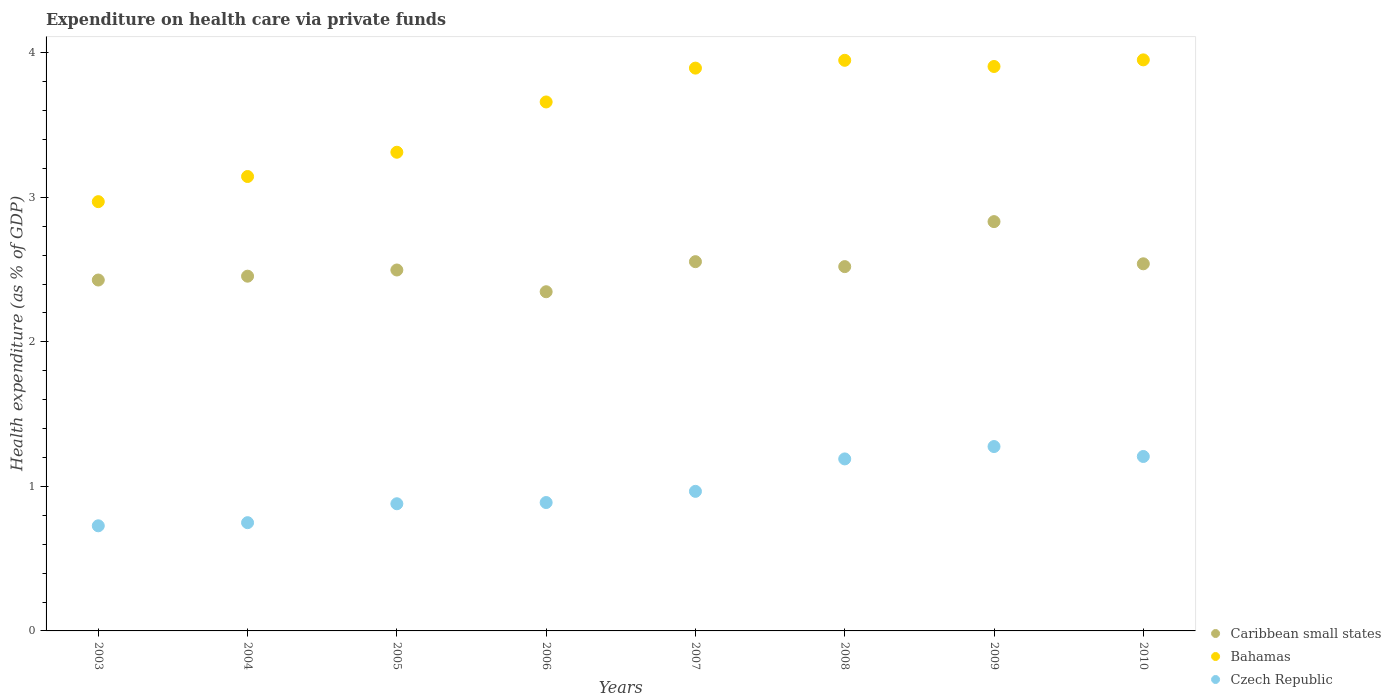Is the number of dotlines equal to the number of legend labels?
Your answer should be compact. Yes. What is the expenditure made on health care in Czech Republic in 2004?
Give a very brief answer. 0.75. Across all years, what is the maximum expenditure made on health care in Caribbean small states?
Your response must be concise. 2.83. Across all years, what is the minimum expenditure made on health care in Bahamas?
Offer a terse response. 2.97. In which year was the expenditure made on health care in Caribbean small states maximum?
Your response must be concise. 2009. In which year was the expenditure made on health care in Czech Republic minimum?
Offer a terse response. 2003. What is the total expenditure made on health care in Caribbean small states in the graph?
Your answer should be very brief. 20.17. What is the difference between the expenditure made on health care in Bahamas in 2006 and that in 2007?
Offer a very short reply. -0.23. What is the difference between the expenditure made on health care in Czech Republic in 2004 and the expenditure made on health care in Bahamas in 2003?
Your answer should be very brief. -2.22. What is the average expenditure made on health care in Czech Republic per year?
Make the answer very short. 0.99. In the year 2003, what is the difference between the expenditure made on health care in Bahamas and expenditure made on health care in Czech Republic?
Ensure brevity in your answer.  2.24. What is the ratio of the expenditure made on health care in Caribbean small states in 2004 to that in 2007?
Make the answer very short. 0.96. Is the expenditure made on health care in Czech Republic in 2005 less than that in 2006?
Your answer should be compact. Yes. Is the difference between the expenditure made on health care in Bahamas in 2006 and 2007 greater than the difference between the expenditure made on health care in Czech Republic in 2006 and 2007?
Keep it short and to the point. No. What is the difference between the highest and the second highest expenditure made on health care in Czech Republic?
Give a very brief answer. 0.07. What is the difference between the highest and the lowest expenditure made on health care in Caribbean small states?
Your answer should be compact. 0.49. In how many years, is the expenditure made on health care in Bahamas greater than the average expenditure made on health care in Bahamas taken over all years?
Your answer should be compact. 5. Is the sum of the expenditure made on health care in Bahamas in 2007 and 2009 greater than the maximum expenditure made on health care in Caribbean small states across all years?
Ensure brevity in your answer.  Yes. Is the expenditure made on health care in Bahamas strictly greater than the expenditure made on health care in Czech Republic over the years?
Offer a terse response. Yes. Is the expenditure made on health care in Czech Republic strictly less than the expenditure made on health care in Caribbean small states over the years?
Ensure brevity in your answer.  Yes. What is the title of the graph?
Provide a succinct answer. Expenditure on health care via private funds. Does "Channel Islands" appear as one of the legend labels in the graph?
Offer a terse response. No. What is the label or title of the Y-axis?
Your response must be concise. Health expenditure (as % of GDP). What is the Health expenditure (as % of GDP) of Caribbean small states in 2003?
Your answer should be very brief. 2.43. What is the Health expenditure (as % of GDP) in Bahamas in 2003?
Provide a succinct answer. 2.97. What is the Health expenditure (as % of GDP) of Czech Republic in 2003?
Your answer should be very brief. 0.73. What is the Health expenditure (as % of GDP) in Caribbean small states in 2004?
Your answer should be very brief. 2.45. What is the Health expenditure (as % of GDP) in Bahamas in 2004?
Offer a terse response. 3.14. What is the Health expenditure (as % of GDP) of Czech Republic in 2004?
Give a very brief answer. 0.75. What is the Health expenditure (as % of GDP) in Caribbean small states in 2005?
Your answer should be compact. 2.5. What is the Health expenditure (as % of GDP) of Bahamas in 2005?
Offer a very short reply. 3.31. What is the Health expenditure (as % of GDP) of Czech Republic in 2005?
Offer a very short reply. 0.88. What is the Health expenditure (as % of GDP) of Caribbean small states in 2006?
Your response must be concise. 2.35. What is the Health expenditure (as % of GDP) in Bahamas in 2006?
Your answer should be very brief. 3.66. What is the Health expenditure (as % of GDP) of Czech Republic in 2006?
Ensure brevity in your answer.  0.89. What is the Health expenditure (as % of GDP) of Caribbean small states in 2007?
Your response must be concise. 2.55. What is the Health expenditure (as % of GDP) of Bahamas in 2007?
Your answer should be very brief. 3.89. What is the Health expenditure (as % of GDP) in Czech Republic in 2007?
Keep it short and to the point. 0.97. What is the Health expenditure (as % of GDP) in Caribbean small states in 2008?
Give a very brief answer. 2.52. What is the Health expenditure (as % of GDP) of Bahamas in 2008?
Offer a terse response. 3.95. What is the Health expenditure (as % of GDP) in Czech Republic in 2008?
Offer a very short reply. 1.19. What is the Health expenditure (as % of GDP) in Caribbean small states in 2009?
Ensure brevity in your answer.  2.83. What is the Health expenditure (as % of GDP) in Bahamas in 2009?
Keep it short and to the point. 3.91. What is the Health expenditure (as % of GDP) in Czech Republic in 2009?
Provide a short and direct response. 1.28. What is the Health expenditure (as % of GDP) of Caribbean small states in 2010?
Your answer should be compact. 2.54. What is the Health expenditure (as % of GDP) in Bahamas in 2010?
Ensure brevity in your answer.  3.95. What is the Health expenditure (as % of GDP) of Czech Republic in 2010?
Give a very brief answer. 1.21. Across all years, what is the maximum Health expenditure (as % of GDP) in Caribbean small states?
Offer a terse response. 2.83. Across all years, what is the maximum Health expenditure (as % of GDP) of Bahamas?
Give a very brief answer. 3.95. Across all years, what is the maximum Health expenditure (as % of GDP) of Czech Republic?
Keep it short and to the point. 1.28. Across all years, what is the minimum Health expenditure (as % of GDP) in Caribbean small states?
Offer a terse response. 2.35. Across all years, what is the minimum Health expenditure (as % of GDP) in Bahamas?
Offer a very short reply. 2.97. Across all years, what is the minimum Health expenditure (as % of GDP) of Czech Republic?
Offer a terse response. 0.73. What is the total Health expenditure (as % of GDP) in Caribbean small states in the graph?
Ensure brevity in your answer.  20.17. What is the total Health expenditure (as % of GDP) in Bahamas in the graph?
Offer a very short reply. 28.78. What is the total Health expenditure (as % of GDP) of Czech Republic in the graph?
Provide a succinct answer. 7.88. What is the difference between the Health expenditure (as % of GDP) in Caribbean small states in 2003 and that in 2004?
Ensure brevity in your answer.  -0.03. What is the difference between the Health expenditure (as % of GDP) of Bahamas in 2003 and that in 2004?
Your answer should be compact. -0.17. What is the difference between the Health expenditure (as % of GDP) in Czech Republic in 2003 and that in 2004?
Give a very brief answer. -0.02. What is the difference between the Health expenditure (as % of GDP) of Caribbean small states in 2003 and that in 2005?
Your answer should be very brief. -0.07. What is the difference between the Health expenditure (as % of GDP) in Bahamas in 2003 and that in 2005?
Ensure brevity in your answer.  -0.34. What is the difference between the Health expenditure (as % of GDP) of Czech Republic in 2003 and that in 2005?
Ensure brevity in your answer.  -0.15. What is the difference between the Health expenditure (as % of GDP) of Caribbean small states in 2003 and that in 2006?
Give a very brief answer. 0.08. What is the difference between the Health expenditure (as % of GDP) of Bahamas in 2003 and that in 2006?
Offer a very short reply. -0.69. What is the difference between the Health expenditure (as % of GDP) in Czech Republic in 2003 and that in 2006?
Offer a terse response. -0.16. What is the difference between the Health expenditure (as % of GDP) in Caribbean small states in 2003 and that in 2007?
Your answer should be very brief. -0.13. What is the difference between the Health expenditure (as % of GDP) of Bahamas in 2003 and that in 2007?
Give a very brief answer. -0.92. What is the difference between the Health expenditure (as % of GDP) in Czech Republic in 2003 and that in 2007?
Your response must be concise. -0.24. What is the difference between the Health expenditure (as % of GDP) of Caribbean small states in 2003 and that in 2008?
Provide a succinct answer. -0.09. What is the difference between the Health expenditure (as % of GDP) in Bahamas in 2003 and that in 2008?
Your answer should be very brief. -0.98. What is the difference between the Health expenditure (as % of GDP) in Czech Republic in 2003 and that in 2008?
Your answer should be very brief. -0.46. What is the difference between the Health expenditure (as % of GDP) of Caribbean small states in 2003 and that in 2009?
Offer a terse response. -0.4. What is the difference between the Health expenditure (as % of GDP) in Bahamas in 2003 and that in 2009?
Your response must be concise. -0.94. What is the difference between the Health expenditure (as % of GDP) of Czech Republic in 2003 and that in 2009?
Offer a terse response. -0.55. What is the difference between the Health expenditure (as % of GDP) of Caribbean small states in 2003 and that in 2010?
Offer a terse response. -0.11. What is the difference between the Health expenditure (as % of GDP) of Bahamas in 2003 and that in 2010?
Keep it short and to the point. -0.98. What is the difference between the Health expenditure (as % of GDP) of Czech Republic in 2003 and that in 2010?
Your response must be concise. -0.48. What is the difference between the Health expenditure (as % of GDP) of Caribbean small states in 2004 and that in 2005?
Provide a succinct answer. -0.04. What is the difference between the Health expenditure (as % of GDP) in Bahamas in 2004 and that in 2005?
Keep it short and to the point. -0.17. What is the difference between the Health expenditure (as % of GDP) in Czech Republic in 2004 and that in 2005?
Ensure brevity in your answer.  -0.13. What is the difference between the Health expenditure (as % of GDP) of Caribbean small states in 2004 and that in 2006?
Provide a succinct answer. 0.11. What is the difference between the Health expenditure (as % of GDP) in Bahamas in 2004 and that in 2006?
Your response must be concise. -0.52. What is the difference between the Health expenditure (as % of GDP) of Czech Republic in 2004 and that in 2006?
Provide a short and direct response. -0.14. What is the difference between the Health expenditure (as % of GDP) in Caribbean small states in 2004 and that in 2007?
Your response must be concise. -0.1. What is the difference between the Health expenditure (as % of GDP) in Bahamas in 2004 and that in 2007?
Offer a very short reply. -0.75. What is the difference between the Health expenditure (as % of GDP) in Czech Republic in 2004 and that in 2007?
Give a very brief answer. -0.22. What is the difference between the Health expenditure (as % of GDP) of Caribbean small states in 2004 and that in 2008?
Keep it short and to the point. -0.07. What is the difference between the Health expenditure (as % of GDP) of Bahamas in 2004 and that in 2008?
Give a very brief answer. -0.8. What is the difference between the Health expenditure (as % of GDP) in Czech Republic in 2004 and that in 2008?
Make the answer very short. -0.44. What is the difference between the Health expenditure (as % of GDP) of Caribbean small states in 2004 and that in 2009?
Provide a succinct answer. -0.38. What is the difference between the Health expenditure (as % of GDP) of Bahamas in 2004 and that in 2009?
Your answer should be compact. -0.76. What is the difference between the Health expenditure (as % of GDP) in Czech Republic in 2004 and that in 2009?
Give a very brief answer. -0.53. What is the difference between the Health expenditure (as % of GDP) of Caribbean small states in 2004 and that in 2010?
Provide a short and direct response. -0.09. What is the difference between the Health expenditure (as % of GDP) in Bahamas in 2004 and that in 2010?
Offer a very short reply. -0.81. What is the difference between the Health expenditure (as % of GDP) in Czech Republic in 2004 and that in 2010?
Keep it short and to the point. -0.46. What is the difference between the Health expenditure (as % of GDP) of Caribbean small states in 2005 and that in 2006?
Give a very brief answer. 0.15. What is the difference between the Health expenditure (as % of GDP) of Bahamas in 2005 and that in 2006?
Offer a terse response. -0.35. What is the difference between the Health expenditure (as % of GDP) of Czech Republic in 2005 and that in 2006?
Give a very brief answer. -0.01. What is the difference between the Health expenditure (as % of GDP) of Caribbean small states in 2005 and that in 2007?
Offer a very short reply. -0.06. What is the difference between the Health expenditure (as % of GDP) in Bahamas in 2005 and that in 2007?
Offer a very short reply. -0.58. What is the difference between the Health expenditure (as % of GDP) of Czech Republic in 2005 and that in 2007?
Your answer should be very brief. -0.09. What is the difference between the Health expenditure (as % of GDP) in Caribbean small states in 2005 and that in 2008?
Provide a short and direct response. -0.02. What is the difference between the Health expenditure (as % of GDP) of Bahamas in 2005 and that in 2008?
Make the answer very short. -0.64. What is the difference between the Health expenditure (as % of GDP) of Czech Republic in 2005 and that in 2008?
Your answer should be compact. -0.31. What is the difference between the Health expenditure (as % of GDP) in Caribbean small states in 2005 and that in 2009?
Your response must be concise. -0.33. What is the difference between the Health expenditure (as % of GDP) in Bahamas in 2005 and that in 2009?
Offer a terse response. -0.59. What is the difference between the Health expenditure (as % of GDP) in Czech Republic in 2005 and that in 2009?
Offer a terse response. -0.4. What is the difference between the Health expenditure (as % of GDP) in Caribbean small states in 2005 and that in 2010?
Provide a succinct answer. -0.04. What is the difference between the Health expenditure (as % of GDP) in Bahamas in 2005 and that in 2010?
Your response must be concise. -0.64. What is the difference between the Health expenditure (as % of GDP) in Czech Republic in 2005 and that in 2010?
Your answer should be very brief. -0.33. What is the difference between the Health expenditure (as % of GDP) in Caribbean small states in 2006 and that in 2007?
Provide a short and direct response. -0.21. What is the difference between the Health expenditure (as % of GDP) in Bahamas in 2006 and that in 2007?
Your answer should be very brief. -0.23. What is the difference between the Health expenditure (as % of GDP) of Czech Republic in 2006 and that in 2007?
Provide a short and direct response. -0.08. What is the difference between the Health expenditure (as % of GDP) of Caribbean small states in 2006 and that in 2008?
Keep it short and to the point. -0.17. What is the difference between the Health expenditure (as % of GDP) in Bahamas in 2006 and that in 2008?
Your answer should be compact. -0.29. What is the difference between the Health expenditure (as % of GDP) of Czech Republic in 2006 and that in 2008?
Keep it short and to the point. -0.3. What is the difference between the Health expenditure (as % of GDP) of Caribbean small states in 2006 and that in 2009?
Provide a succinct answer. -0.49. What is the difference between the Health expenditure (as % of GDP) in Bahamas in 2006 and that in 2009?
Ensure brevity in your answer.  -0.25. What is the difference between the Health expenditure (as % of GDP) in Czech Republic in 2006 and that in 2009?
Offer a very short reply. -0.39. What is the difference between the Health expenditure (as % of GDP) in Caribbean small states in 2006 and that in 2010?
Provide a short and direct response. -0.19. What is the difference between the Health expenditure (as % of GDP) in Bahamas in 2006 and that in 2010?
Your answer should be very brief. -0.29. What is the difference between the Health expenditure (as % of GDP) of Czech Republic in 2006 and that in 2010?
Ensure brevity in your answer.  -0.32. What is the difference between the Health expenditure (as % of GDP) in Caribbean small states in 2007 and that in 2008?
Your response must be concise. 0.03. What is the difference between the Health expenditure (as % of GDP) in Bahamas in 2007 and that in 2008?
Offer a terse response. -0.05. What is the difference between the Health expenditure (as % of GDP) in Czech Republic in 2007 and that in 2008?
Your response must be concise. -0.22. What is the difference between the Health expenditure (as % of GDP) in Caribbean small states in 2007 and that in 2009?
Your response must be concise. -0.28. What is the difference between the Health expenditure (as % of GDP) of Bahamas in 2007 and that in 2009?
Make the answer very short. -0.01. What is the difference between the Health expenditure (as % of GDP) in Czech Republic in 2007 and that in 2009?
Ensure brevity in your answer.  -0.31. What is the difference between the Health expenditure (as % of GDP) in Caribbean small states in 2007 and that in 2010?
Ensure brevity in your answer.  0.01. What is the difference between the Health expenditure (as % of GDP) in Bahamas in 2007 and that in 2010?
Provide a succinct answer. -0.06. What is the difference between the Health expenditure (as % of GDP) in Czech Republic in 2007 and that in 2010?
Provide a succinct answer. -0.24. What is the difference between the Health expenditure (as % of GDP) of Caribbean small states in 2008 and that in 2009?
Ensure brevity in your answer.  -0.31. What is the difference between the Health expenditure (as % of GDP) in Bahamas in 2008 and that in 2009?
Provide a succinct answer. 0.04. What is the difference between the Health expenditure (as % of GDP) of Czech Republic in 2008 and that in 2009?
Provide a succinct answer. -0.09. What is the difference between the Health expenditure (as % of GDP) of Caribbean small states in 2008 and that in 2010?
Provide a short and direct response. -0.02. What is the difference between the Health expenditure (as % of GDP) of Bahamas in 2008 and that in 2010?
Your answer should be compact. -0. What is the difference between the Health expenditure (as % of GDP) in Czech Republic in 2008 and that in 2010?
Give a very brief answer. -0.02. What is the difference between the Health expenditure (as % of GDP) in Caribbean small states in 2009 and that in 2010?
Provide a succinct answer. 0.29. What is the difference between the Health expenditure (as % of GDP) of Bahamas in 2009 and that in 2010?
Offer a terse response. -0.05. What is the difference between the Health expenditure (as % of GDP) of Czech Republic in 2009 and that in 2010?
Keep it short and to the point. 0.07. What is the difference between the Health expenditure (as % of GDP) of Caribbean small states in 2003 and the Health expenditure (as % of GDP) of Bahamas in 2004?
Offer a very short reply. -0.72. What is the difference between the Health expenditure (as % of GDP) of Caribbean small states in 2003 and the Health expenditure (as % of GDP) of Czech Republic in 2004?
Provide a succinct answer. 1.68. What is the difference between the Health expenditure (as % of GDP) in Bahamas in 2003 and the Health expenditure (as % of GDP) in Czech Republic in 2004?
Offer a terse response. 2.22. What is the difference between the Health expenditure (as % of GDP) in Caribbean small states in 2003 and the Health expenditure (as % of GDP) in Bahamas in 2005?
Provide a short and direct response. -0.88. What is the difference between the Health expenditure (as % of GDP) in Caribbean small states in 2003 and the Health expenditure (as % of GDP) in Czech Republic in 2005?
Your answer should be very brief. 1.55. What is the difference between the Health expenditure (as % of GDP) in Bahamas in 2003 and the Health expenditure (as % of GDP) in Czech Republic in 2005?
Keep it short and to the point. 2.09. What is the difference between the Health expenditure (as % of GDP) of Caribbean small states in 2003 and the Health expenditure (as % of GDP) of Bahamas in 2006?
Your answer should be compact. -1.23. What is the difference between the Health expenditure (as % of GDP) of Caribbean small states in 2003 and the Health expenditure (as % of GDP) of Czech Republic in 2006?
Provide a succinct answer. 1.54. What is the difference between the Health expenditure (as % of GDP) in Bahamas in 2003 and the Health expenditure (as % of GDP) in Czech Republic in 2006?
Offer a terse response. 2.08. What is the difference between the Health expenditure (as % of GDP) in Caribbean small states in 2003 and the Health expenditure (as % of GDP) in Bahamas in 2007?
Provide a succinct answer. -1.47. What is the difference between the Health expenditure (as % of GDP) of Caribbean small states in 2003 and the Health expenditure (as % of GDP) of Czech Republic in 2007?
Your response must be concise. 1.46. What is the difference between the Health expenditure (as % of GDP) in Bahamas in 2003 and the Health expenditure (as % of GDP) in Czech Republic in 2007?
Make the answer very short. 2. What is the difference between the Health expenditure (as % of GDP) of Caribbean small states in 2003 and the Health expenditure (as % of GDP) of Bahamas in 2008?
Your answer should be compact. -1.52. What is the difference between the Health expenditure (as % of GDP) in Caribbean small states in 2003 and the Health expenditure (as % of GDP) in Czech Republic in 2008?
Provide a succinct answer. 1.24. What is the difference between the Health expenditure (as % of GDP) in Bahamas in 2003 and the Health expenditure (as % of GDP) in Czech Republic in 2008?
Give a very brief answer. 1.78. What is the difference between the Health expenditure (as % of GDP) of Caribbean small states in 2003 and the Health expenditure (as % of GDP) of Bahamas in 2009?
Ensure brevity in your answer.  -1.48. What is the difference between the Health expenditure (as % of GDP) of Caribbean small states in 2003 and the Health expenditure (as % of GDP) of Czech Republic in 2009?
Your answer should be compact. 1.15. What is the difference between the Health expenditure (as % of GDP) in Bahamas in 2003 and the Health expenditure (as % of GDP) in Czech Republic in 2009?
Provide a succinct answer. 1.69. What is the difference between the Health expenditure (as % of GDP) in Caribbean small states in 2003 and the Health expenditure (as % of GDP) in Bahamas in 2010?
Provide a short and direct response. -1.52. What is the difference between the Health expenditure (as % of GDP) in Caribbean small states in 2003 and the Health expenditure (as % of GDP) in Czech Republic in 2010?
Provide a succinct answer. 1.22. What is the difference between the Health expenditure (as % of GDP) of Bahamas in 2003 and the Health expenditure (as % of GDP) of Czech Republic in 2010?
Provide a short and direct response. 1.76. What is the difference between the Health expenditure (as % of GDP) of Caribbean small states in 2004 and the Health expenditure (as % of GDP) of Bahamas in 2005?
Keep it short and to the point. -0.86. What is the difference between the Health expenditure (as % of GDP) in Caribbean small states in 2004 and the Health expenditure (as % of GDP) in Czech Republic in 2005?
Offer a very short reply. 1.57. What is the difference between the Health expenditure (as % of GDP) in Bahamas in 2004 and the Health expenditure (as % of GDP) in Czech Republic in 2005?
Your response must be concise. 2.26. What is the difference between the Health expenditure (as % of GDP) in Caribbean small states in 2004 and the Health expenditure (as % of GDP) in Bahamas in 2006?
Keep it short and to the point. -1.21. What is the difference between the Health expenditure (as % of GDP) of Caribbean small states in 2004 and the Health expenditure (as % of GDP) of Czech Republic in 2006?
Ensure brevity in your answer.  1.57. What is the difference between the Health expenditure (as % of GDP) of Bahamas in 2004 and the Health expenditure (as % of GDP) of Czech Republic in 2006?
Ensure brevity in your answer.  2.26. What is the difference between the Health expenditure (as % of GDP) of Caribbean small states in 2004 and the Health expenditure (as % of GDP) of Bahamas in 2007?
Your answer should be very brief. -1.44. What is the difference between the Health expenditure (as % of GDP) in Caribbean small states in 2004 and the Health expenditure (as % of GDP) in Czech Republic in 2007?
Offer a terse response. 1.49. What is the difference between the Health expenditure (as % of GDP) in Bahamas in 2004 and the Health expenditure (as % of GDP) in Czech Republic in 2007?
Ensure brevity in your answer.  2.18. What is the difference between the Health expenditure (as % of GDP) in Caribbean small states in 2004 and the Health expenditure (as % of GDP) in Bahamas in 2008?
Ensure brevity in your answer.  -1.49. What is the difference between the Health expenditure (as % of GDP) of Caribbean small states in 2004 and the Health expenditure (as % of GDP) of Czech Republic in 2008?
Keep it short and to the point. 1.26. What is the difference between the Health expenditure (as % of GDP) in Bahamas in 2004 and the Health expenditure (as % of GDP) in Czech Republic in 2008?
Give a very brief answer. 1.95. What is the difference between the Health expenditure (as % of GDP) in Caribbean small states in 2004 and the Health expenditure (as % of GDP) in Bahamas in 2009?
Keep it short and to the point. -1.45. What is the difference between the Health expenditure (as % of GDP) of Caribbean small states in 2004 and the Health expenditure (as % of GDP) of Czech Republic in 2009?
Your answer should be compact. 1.18. What is the difference between the Health expenditure (as % of GDP) in Bahamas in 2004 and the Health expenditure (as % of GDP) in Czech Republic in 2009?
Give a very brief answer. 1.87. What is the difference between the Health expenditure (as % of GDP) of Caribbean small states in 2004 and the Health expenditure (as % of GDP) of Bahamas in 2010?
Offer a very short reply. -1.5. What is the difference between the Health expenditure (as % of GDP) of Caribbean small states in 2004 and the Health expenditure (as % of GDP) of Czech Republic in 2010?
Provide a succinct answer. 1.25. What is the difference between the Health expenditure (as % of GDP) of Bahamas in 2004 and the Health expenditure (as % of GDP) of Czech Republic in 2010?
Your response must be concise. 1.94. What is the difference between the Health expenditure (as % of GDP) of Caribbean small states in 2005 and the Health expenditure (as % of GDP) of Bahamas in 2006?
Keep it short and to the point. -1.16. What is the difference between the Health expenditure (as % of GDP) in Caribbean small states in 2005 and the Health expenditure (as % of GDP) in Czech Republic in 2006?
Offer a very short reply. 1.61. What is the difference between the Health expenditure (as % of GDP) of Bahamas in 2005 and the Health expenditure (as % of GDP) of Czech Republic in 2006?
Make the answer very short. 2.42. What is the difference between the Health expenditure (as % of GDP) in Caribbean small states in 2005 and the Health expenditure (as % of GDP) in Bahamas in 2007?
Provide a short and direct response. -1.4. What is the difference between the Health expenditure (as % of GDP) of Caribbean small states in 2005 and the Health expenditure (as % of GDP) of Czech Republic in 2007?
Provide a short and direct response. 1.53. What is the difference between the Health expenditure (as % of GDP) in Bahamas in 2005 and the Health expenditure (as % of GDP) in Czech Republic in 2007?
Give a very brief answer. 2.35. What is the difference between the Health expenditure (as % of GDP) in Caribbean small states in 2005 and the Health expenditure (as % of GDP) in Bahamas in 2008?
Offer a very short reply. -1.45. What is the difference between the Health expenditure (as % of GDP) in Caribbean small states in 2005 and the Health expenditure (as % of GDP) in Czech Republic in 2008?
Make the answer very short. 1.31. What is the difference between the Health expenditure (as % of GDP) in Bahamas in 2005 and the Health expenditure (as % of GDP) in Czech Republic in 2008?
Your answer should be compact. 2.12. What is the difference between the Health expenditure (as % of GDP) of Caribbean small states in 2005 and the Health expenditure (as % of GDP) of Bahamas in 2009?
Provide a succinct answer. -1.41. What is the difference between the Health expenditure (as % of GDP) of Caribbean small states in 2005 and the Health expenditure (as % of GDP) of Czech Republic in 2009?
Provide a succinct answer. 1.22. What is the difference between the Health expenditure (as % of GDP) of Bahamas in 2005 and the Health expenditure (as % of GDP) of Czech Republic in 2009?
Offer a terse response. 2.04. What is the difference between the Health expenditure (as % of GDP) of Caribbean small states in 2005 and the Health expenditure (as % of GDP) of Bahamas in 2010?
Offer a terse response. -1.45. What is the difference between the Health expenditure (as % of GDP) of Caribbean small states in 2005 and the Health expenditure (as % of GDP) of Czech Republic in 2010?
Offer a terse response. 1.29. What is the difference between the Health expenditure (as % of GDP) of Bahamas in 2005 and the Health expenditure (as % of GDP) of Czech Republic in 2010?
Your answer should be compact. 2.1. What is the difference between the Health expenditure (as % of GDP) in Caribbean small states in 2006 and the Health expenditure (as % of GDP) in Bahamas in 2007?
Keep it short and to the point. -1.55. What is the difference between the Health expenditure (as % of GDP) of Caribbean small states in 2006 and the Health expenditure (as % of GDP) of Czech Republic in 2007?
Offer a terse response. 1.38. What is the difference between the Health expenditure (as % of GDP) of Bahamas in 2006 and the Health expenditure (as % of GDP) of Czech Republic in 2007?
Provide a succinct answer. 2.69. What is the difference between the Health expenditure (as % of GDP) of Caribbean small states in 2006 and the Health expenditure (as % of GDP) of Bahamas in 2008?
Your response must be concise. -1.6. What is the difference between the Health expenditure (as % of GDP) in Caribbean small states in 2006 and the Health expenditure (as % of GDP) in Czech Republic in 2008?
Make the answer very short. 1.16. What is the difference between the Health expenditure (as % of GDP) of Bahamas in 2006 and the Health expenditure (as % of GDP) of Czech Republic in 2008?
Keep it short and to the point. 2.47. What is the difference between the Health expenditure (as % of GDP) of Caribbean small states in 2006 and the Health expenditure (as % of GDP) of Bahamas in 2009?
Make the answer very short. -1.56. What is the difference between the Health expenditure (as % of GDP) in Caribbean small states in 2006 and the Health expenditure (as % of GDP) in Czech Republic in 2009?
Your answer should be compact. 1.07. What is the difference between the Health expenditure (as % of GDP) of Bahamas in 2006 and the Health expenditure (as % of GDP) of Czech Republic in 2009?
Your answer should be very brief. 2.38. What is the difference between the Health expenditure (as % of GDP) of Caribbean small states in 2006 and the Health expenditure (as % of GDP) of Bahamas in 2010?
Your answer should be very brief. -1.6. What is the difference between the Health expenditure (as % of GDP) in Caribbean small states in 2006 and the Health expenditure (as % of GDP) in Czech Republic in 2010?
Your answer should be very brief. 1.14. What is the difference between the Health expenditure (as % of GDP) in Bahamas in 2006 and the Health expenditure (as % of GDP) in Czech Republic in 2010?
Keep it short and to the point. 2.45. What is the difference between the Health expenditure (as % of GDP) of Caribbean small states in 2007 and the Health expenditure (as % of GDP) of Bahamas in 2008?
Offer a terse response. -1.39. What is the difference between the Health expenditure (as % of GDP) of Caribbean small states in 2007 and the Health expenditure (as % of GDP) of Czech Republic in 2008?
Your response must be concise. 1.36. What is the difference between the Health expenditure (as % of GDP) in Bahamas in 2007 and the Health expenditure (as % of GDP) in Czech Republic in 2008?
Offer a terse response. 2.7. What is the difference between the Health expenditure (as % of GDP) in Caribbean small states in 2007 and the Health expenditure (as % of GDP) in Bahamas in 2009?
Offer a very short reply. -1.35. What is the difference between the Health expenditure (as % of GDP) in Caribbean small states in 2007 and the Health expenditure (as % of GDP) in Czech Republic in 2009?
Your answer should be very brief. 1.28. What is the difference between the Health expenditure (as % of GDP) of Bahamas in 2007 and the Health expenditure (as % of GDP) of Czech Republic in 2009?
Ensure brevity in your answer.  2.62. What is the difference between the Health expenditure (as % of GDP) of Caribbean small states in 2007 and the Health expenditure (as % of GDP) of Bahamas in 2010?
Provide a short and direct response. -1.4. What is the difference between the Health expenditure (as % of GDP) of Caribbean small states in 2007 and the Health expenditure (as % of GDP) of Czech Republic in 2010?
Give a very brief answer. 1.35. What is the difference between the Health expenditure (as % of GDP) of Bahamas in 2007 and the Health expenditure (as % of GDP) of Czech Republic in 2010?
Provide a short and direct response. 2.69. What is the difference between the Health expenditure (as % of GDP) of Caribbean small states in 2008 and the Health expenditure (as % of GDP) of Bahamas in 2009?
Your answer should be compact. -1.38. What is the difference between the Health expenditure (as % of GDP) of Caribbean small states in 2008 and the Health expenditure (as % of GDP) of Czech Republic in 2009?
Provide a succinct answer. 1.24. What is the difference between the Health expenditure (as % of GDP) of Bahamas in 2008 and the Health expenditure (as % of GDP) of Czech Republic in 2009?
Provide a short and direct response. 2.67. What is the difference between the Health expenditure (as % of GDP) in Caribbean small states in 2008 and the Health expenditure (as % of GDP) in Bahamas in 2010?
Keep it short and to the point. -1.43. What is the difference between the Health expenditure (as % of GDP) in Caribbean small states in 2008 and the Health expenditure (as % of GDP) in Czech Republic in 2010?
Your answer should be very brief. 1.31. What is the difference between the Health expenditure (as % of GDP) of Bahamas in 2008 and the Health expenditure (as % of GDP) of Czech Republic in 2010?
Ensure brevity in your answer.  2.74. What is the difference between the Health expenditure (as % of GDP) in Caribbean small states in 2009 and the Health expenditure (as % of GDP) in Bahamas in 2010?
Ensure brevity in your answer.  -1.12. What is the difference between the Health expenditure (as % of GDP) of Caribbean small states in 2009 and the Health expenditure (as % of GDP) of Czech Republic in 2010?
Give a very brief answer. 1.62. What is the difference between the Health expenditure (as % of GDP) of Bahamas in 2009 and the Health expenditure (as % of GDP) of Czech Republic in 2010?
Make the answer very short. 2.7. What is the average Health expenditure (as % of GDP) of Caribbean small states per year?
Make the answer very short. 2.52. What is the average Health expenditure (as % of GDP) of Bahamas per year?
Offer a terse response. 3.6. What is the average Health expenditure (as % of GDP) of Czech Republic per year?
Provide a succinct answer. 0.99. In the year 2003, what is the difference between the Health expenditure (as % of GDP) of Caribbean small states and Health expenditure (as % of GDP) of Bahamas?
Make the answer very short. -0.54. In the year 2003, what is the difference between the Health expenditure (as % of GDP) of Caribbean small states and Health expenditure (as % of GDP) of Czech Republic?
Ensure brevity in your answer.  1.7. In the year 2003, what is the difference between the Health expenditure (as % of GDP) in Bahamas and Health expenditure (as % of GDP) in Czech Republic?
Provide a short and direct response. 2.24. In the year 2004, what is the difference between the Health expenditure (as % of GDP) in Caribbean small states and Health expenditure (as % of GDP) in Bahamas?
Offer a terse response. -0.69. In the year 2004, what is the difference between the Health expenditure (as % of GDP) in Caribbean small states and Health expenditure (as % of GDP) in Czech Republic?
Your answer should be very brief. 1.71. In the year 2004, what is the difference between the Health expenditure (as % of GDP) in Bahamas and Health expenditure (as % of GDP) in Czech Republic?
Keep it short and to the point. 2.4. In the year 2005, what is the difference between the Health expenditure (as % of GDP) of Caribbean small states and Health expenditure (as % of GDP) of Bahamas?
Provide a succinct answer. -0.81. In the year 2005, what is the difference between the Health expenditure (as % of GDP) in Caribbean small states and Health expenditure (as % of GDP) in Czech Republic?
Provide a short and direct response. 1.62. In the year 2005, what is the difference between the Health expenditure (as % of GDP) in Bahamas and Health expenditure (as % of GDP) in Czech Republic?
Provide a short and direct response. 2.43. In the year 2006, what is the difference between the Health expenditure (as % of GDP) of Caribbean small states and Health expenditure (as % of GDP) of Bahamas?
Ensure brevity in your answer.  -1.31. In the year 2006, what is the difference between the Health expenditure (as % of GDP) in Caribbean small states and Health expenditure (as % of GDP) in Czech Republic?
Offer a terse response. 1.46. In the year 2006, what is the difference between the Health expenditure (as % of GDP) of Bahamas and Health expenditure (as % of GDP) of Czech Republic?
Keep it short and to the point. 2.77. In the year 2007, what is the difference between the Health expenditure (as % of GDP) in Caribbean small states and Health expenditure (as % of GDP) in Bahamas?
Provide a short and direct response. -1.34. In the year 2007, what is the difference between the Health expenditure (as % of GDP) of Caribbean small states and Health expenditure (as % of GDP) of Czech Republic?
Your answer should be compact. 1.59. In the year 2007, what is the difference between the Health expenditure (as % of GDP) in Bahamas and Health expenditure (as % of GDP) in Czech Republic?
Your answer should be compact. 2.93. In the year 2008, what is the difference between the Health expenditure (as % of GDP) in Caribbean small states and Health expenditure (as % of GDP) in Bahamas?
Your answer should be very brief. -1.43. In the year 2008, what is the difference between the Health expenditure (as % of GDP) of Caribbean small states and Health expenditure (as % of GDP) of Czech Republic?
Keep it short and to the point. 1.33. In the year 2008, what is the difference between the Health expenditure (as % of GDP) of Bahamas and Health expenditure (as % of GDP) of Czech Republic?
Offer a terse response. 2.76. In the year 2009, what is the difference between the Health expenditure (as % of GDP) in Caribbean small states and Health expenditure (as % of GDP) in Bahamas?
Give a very brief answer. -1.07. In the year 2009, what is the difference between the Health expenditure (as % of GDP) of Caribbean small states and Health expenditure (as % of GDP) of Czech Republic?
Offer a very short reply. 1.56. In the year 2009, what is the difference between the Health expenditure (as % of GDP) in Bahamas and Health expenditure (as % of GDP) in Czech Republic?
Make the answer very short. 2.63. In the year 2010, what is the difference between the Health expenditure (as % of GDP) of Caribbean small states and Health expenditure (as % of GDP) of Bahamas?
Your response must be concise. -1.41. In the year 2010, what is the difference between the Health expenditure (as % of GDP) in Caribbean small states and Health expenditure (as % of GDP) in Czech Republic?
Give a very brief answer. 1.33. In the year 2010, what is the difference between the Health expenditure (as % of GDP) of Bahamas and Health expenditure (as % of GDP) of Czech Republic?
Your answer should be very brief. 2.74. What is the ratio of the Health expenditure (as % of GDP) of Caribbean small states in 2003 to that in 2004?
Offer a very short reply. 0.99. What is the ratio of the Health expenditure (as % of GDP) of Bahamas in 2003 to that in 2004?
Offer a terse response. 0.94. What is the ratio of the Health expenditure (as % of GDP) of Czech Republic in 2003 to that in 2004?
Provide a short and direct response. 0.97. What is the ratio of the Health expenditure (as % of GDP) of Caribbean small states in 2003 to that in 2005?
Offer a very short reply. 0.97. What is the ratio of the Health expenditure (as % of GDP) in Bahamas in 2003 to that in 2005?
Your answer should be very brief. 0.9. What is the ratio of the Health expenditure (as % of GDP) of Czech Republic in 2003 to that in 2005?
Your answer should be very brief. 0.83. What is the ratio of the Health expenditure (as % of GDP) of Caribbean small states in 2003 to that in 2006?
Offer a very short reply. 1.03. What is the ratio of the Health expenditure (as % of GDP) of Bahamas in 2003 to that in 2006?
Offer a terse response. 0.81. What is the ratio of the Health expenditure (as % of GDP) in Czech Republic in 2003 to that in 2006?
Provide a succinct answer. 0.82. What is the ratio of the Health expenditure (as % of GDP) of Caribbean small states in 2003 to that in 2007?
Ensure brevity in your answer.  0.95. What is the ratio of the Health expenditure (as % of GDP) of Bahamas in 2003 to that in 2007?
Ensure brevity in your answer.  0.76. What is the ratio of the Health expenditure (as % of GDP) of Czech Republic in 2003 to that in 2007?
Offer a very short reply. 0.75. What is the ratio of the Health expenditure (as % of GDP) in Caribbean small states in 2003 to that in 2008?
Offer a very short reply. 0.96. What is the ratio of the Health expenditure (as % of GDP) in Bahamas in 2003 to that in 2008?
Make the answer very short. 0.75. What is the ratio of the Health expenditure (as % of GDP) in Czech Republic in 2003 to that in 2008?
Make the answer very short. 0.61. What is the ratio of the Health expenditure (as % of GDP) of Caribbean small states in 2003 to that in 2009?
Provide a short and direct response. 0.86. What is the ratio of the Health expenditure (as % of GDP) in Bahamas in 2003 to that in 2009?
Provide a short and direct response. 0.76. What is the ratio of the Health expenditure (as % of GDP) of Czech Republic in 2003 to that in 2009?
Your answer should be compact. 0.57. What is the ratio of the Health expenditure (as % of GDP) of Caribbean small states in 2003 to that in 2010?
Give a very brief answer. 0.96. What is the ratio of the Health expenditure (as % of GDP) of Bahamas in 2003 to that in 2010?
Provide a succinct answer. 0.75. What is the ratio of the Health expenditure (as % of GDP) in Czech Republic in 2003 to that in 2010?
Provide a succinct answer. 0.6. What is the ratio of the Health expenditure (as % of GDP) in Caribbean small states in 2004 to that in 2005?
Offer a terse response. 0.98. What is the ratio of the Health expenditure (as % of GDP) in Bahamas in 2004 to that in 2005?
Your answer should be compact. 0.95. What is the ratio of the Health expenditure (as % of GDP) of Czech Republic in 2004 to that in 2005?
Your answer should be compact. 0.85. What is the ratio of the Health expenditure (as % of GDP) in Caribbean small states in 2004 to that in 2006?
Keep it short and to the point. 1.05. What is the ratio of the Health expenditure (as % of GDP) in Bahamas in 2004 to that in 2006?
Provide a succinct answer. 0.86. What is the ratio of the Health expenditure (as % of GDP) in Czech Republic in 2004 to that in 2006?
Your answer should be very brief. 0.84. What is the ratio of the Health expenditure (as % of GDP) in Caribbean small states in 2004 to that in 2007?
Keep it short and to the point. 0.96. What is the ratio of the Health expenditure (as % of GDP) of Bahamas in 2004 to that in 2007?
Make the answer very short. 0.81. What is the ratio of the Health expenditure (as % of GDP) of Czech Republic in 2004 to that in 2007?
Your answer should be very brief. 0.78. What is the ratio of the Health expenditure (as % of GDP) in Caribbean small states in 2004 to that in 2008?
Your response must be concise. 0.97. What is the ratio of the Health expenditure (as % of GDP) in Bahamas in 2004 to that in 2008?
Give a very brief answer. 0.8. What is the ratio of the Health expenditure (as % of GDP) of Czech Republic in 2004 to that in 2008?
Give a very brief answer. 0.63. What is the ratio of the Health expenditure (as % of GDP) of Caribbean small states in 2004 to that in 2009?
Keep it short and to the point. 0.87. What is the ratio of the Health expenditure (as % of GDP) of Bahamas in 2004 to that in 2009?
Make the answer very short. 0.81. What is the ratio of the Health expenditure (as % of GDP) in Czech Republic in 2004 to that in 2009?
Your answer should be very brief. 0.59. What is the ratio of the Health expenditure (as % of GDP) of Caribbean small states in 2004 to that in 2010?
Provide a short and direct response. 0.97. What is the ratio of the Health expenditure (as % of GDP) of Bahamas in 2004 to that in 2010?
Your answer should be very brief. 0.8. What is the ratio of the Health expenditure (as % of GDP) of Czech Republic in 2004 to that in 2010?
Your answer should be very brief. 0.62. What is the ratio of the Health expenditure (as % of GDP) in Caribbean small states in 2005 to that in 2006?
Give a very brief answer. 1.06. What is the ratio of the Health expenditure (as % of GDP) of Bahamas in 2005 to that in 2006?
Offer a very short reply. 0.9. What is the ratio of the Health expenditure (as % of GDP) in Czech Republic in 2005 to that in 2006?
Your answer should be very brief. 0.99. What is the ratio of the Health expenditure (as % of GDP) in Caribbean small states in 2005 to that in 2007?
Offer a very short reply. 0.98. What is the ratio of the Health expenditure (as % of GDP) of Bahamas in 2005 to that in 2007?
Provide a succinct answer. 0.85. What is the ratio of the Health expenditure (as % of GDP) in Czech Republic in 2005 to that in 2007?
Offer a terse response. 0.91. What is the ratio of the Health expenditure (as % of GDP) of Bahamas in 2005 to that in 2008?
Offer a terse response. 0.84. What is the ratio of the Health expenditure (as % of GDP) of Czech Republic in 2005 to that in 2008?
Give a very brief answer. 0.74. What is the ratio of the Health expenditure (as % of GDP) of Caribbean small states in 2005 to that in 2009?
Provide a succinct answer. 0.88. What is the ratio of the Health expenditure (as % of GDP) of Bahamas in 2005 to that in 2009?
Your answer should be compact. 0.85. What is the ratio of the Health expenditure (as % of GDP) of Czech Republic in 2005 to that in 2009?
Provide a succinct answer. 0.69. What is the ratio of the Health expenditure (as % of GDP) of Caribbean small states in 2005 to that in 2010?
Provide a succinct answer. 0.98. What is the ratio of the Health expenditure (as % of GDP) of Bahamas in 2005 to that in 2010?
Make the answer very short. 0.84. What is the ratio of the Health expenditure (as % of GDP) in Czech Republic in 2005 to that in 2010?
Your answer should be very brief. 0.73. What is the ratio of the Health expenditure (as % of GDP) in Caribbean small states in 2006 to that in 2007?
Provide a succinct answer. 0.92. What is the ratio of the Health expenditure (as % of GDP) of Bahamas in 2006 to that in 2007?
Your response must be concise. 0.94. What is the ratio of the Health expenditure (as % of GDP) of Czech Republic in 2006 to that in 2007?
Provide a succinct answer. 0.92. What is the ratio of the Health expenditure (as % of GDP) of Caribbean small states in 2006 to that in 2008?
Offer a very short reply. 0.93. What is the ratio of the Health expenditure (as % of GDP) in Bahamas in 2006 to that in 2008?
Provide a succinct answer. 0.93. What is the ratio of the Health expenditure (as % of GDP) of Czech Republic in 2006 to that in 2008?
Give a very brief answer. 0.75. What is the ratio of the Health expenditure (as % of GDP) in Caribbean small states in 2006 to that in 2009?
Make the answer very short. 0.83. What is the ratio of the Health expenditure (as % of GDP) of Bahamas in 2006 to that in 2009?
Ensure brevity in your answer.  0.94. What is the ratio of the Health expenditure (as % of GDP) of Czech Republic in 2006 to that in 2009?
Your response must be concise. 0.7. What is the ratio of the Health expenditure (as % of GDP) of Caribbean small states in 2006 to that in 2010?
Offer a terse response. 0.92. What is the ratio of the Health expenditure (as % of GDP) in Bahamas in 2006 to that in 2010?
Your answer should be compact. 0.93. What is the ratio of the Health expenditure (as % of GDP) in Czech Republic in 2006 to that in 2010?
Provide a succinct answer. 0.74. What is the ratio of the Health expenditure (as % of GDP) in Caribbean small states in 2007 to that in 2008?
Your response must be concise. 1.01. What is the ratio of the Health expenditure (as % of GDP) of Bahamas in 2007 to that in 2008?
Offer a very short reply. 0.99. What is the ratio of the Health expenditure (as % of GDP) of Czech Republic in 2007 to that in 2008?
Your answer should be compact. 0.81. What is the ratio of the Health expenditure (as % of GDP) in Caribbean small states in 2007 to that in 2009?
Ensure brevity in your answer.  0.9. What is the ratio of the Health expenditure (as % of GDP) in Bahamas in 2007 to that in 2009?
Your answer should be compact. 1. What is the ratio of the Health expenditure (as % of GDP) in Czech Republic in 2007 to that in 2009?
Offer a very short reply. 0.76. What is the ratio of the Health expenditure (as % of GDP) in Caribbean small states in 2007 to that in 2010?
Offer a terse response. 1.01. What is the ratio of the Health expenditure (as % of GDP) in Bahamas in 2007 to that in 2010?
Keep it short and to the point. 0.99. What is the ratio of the Health expenditure (as % of GDP) in Czech Republic in 2007 to that in 2010?
Ensure brevity in your answer.  0.8. What is the ratio of the Health expenditure (as % of GDP) in Caribbean small states in 2008 to that in 2009?
Offer a terse response. 0.89. What is the ratio of the Health expenditure (as % of GDP) in Bahamas in 2008 to that in 2009?
Offer a terse response. 1.01. What is the ratio of the Health expenditure (as % of GDP) of Czech Republic in 2008 to that in 2009?
Provide a short and direct response. 0.93. What is the ratio of the Health expenditure (as % of GDP) of Czech Republic in 2008 to that in 2010?
Offer a very short reply. 0.99. What is the ratio of the Health expenditure (as % of GDP) in Caribbean small states in 2009 to that in 2010?
Ensure brevity in your answer.  1.11. What is the ratio of the Health expenditure (as % of GDP) in Bahamas in 2009 to that in 2010?
Ensure brevity in your answer.  0.99. What is the ratio of the Health expenditure (as % of GDP) of Czech Republic in 2009 to that in 2010?
Keep it short and to the point. 1.06. What is the difference between the highest and the second highest Health expenditure (as % of GDP) in Caribbean small states?
Provide a succinct answer. 0.28. What is the difference between the highest and the second highest Health expenditure (as % of GDP) of Bahamas?
Your response must be concise. 0. What is the difference between the highest and the second highest Health expenditure (as % of GDP) in Czech Republic?
Offer a terse response. 0.07. What is the difference between the highest and the lowest Health expenditure (as % of GDP) of Caribbean small states?
Your answer should be very brief. 0.49. What is the difference between the highest and the lowest Health expenditure (as % of GDP) in Bahamas?
Provide a succinct answer. 0.98. What is the difference between the highest and the lowest Health expenditure (as % of GDP) in Czech Republic?
Your answer should be very brief. 0.55. 